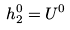<formula> <loc_0><loc_0><loc_500><loc_500>h _ { 2 } ^ { 0 } = U ^ { 0 }</formula> 